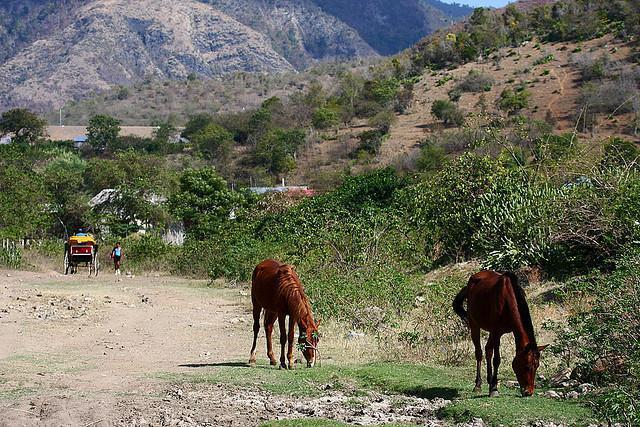How many horses are visible?
Give a very brief answer. 2. How many skateboard wheels are there?
Give a very brief answer. 0. 